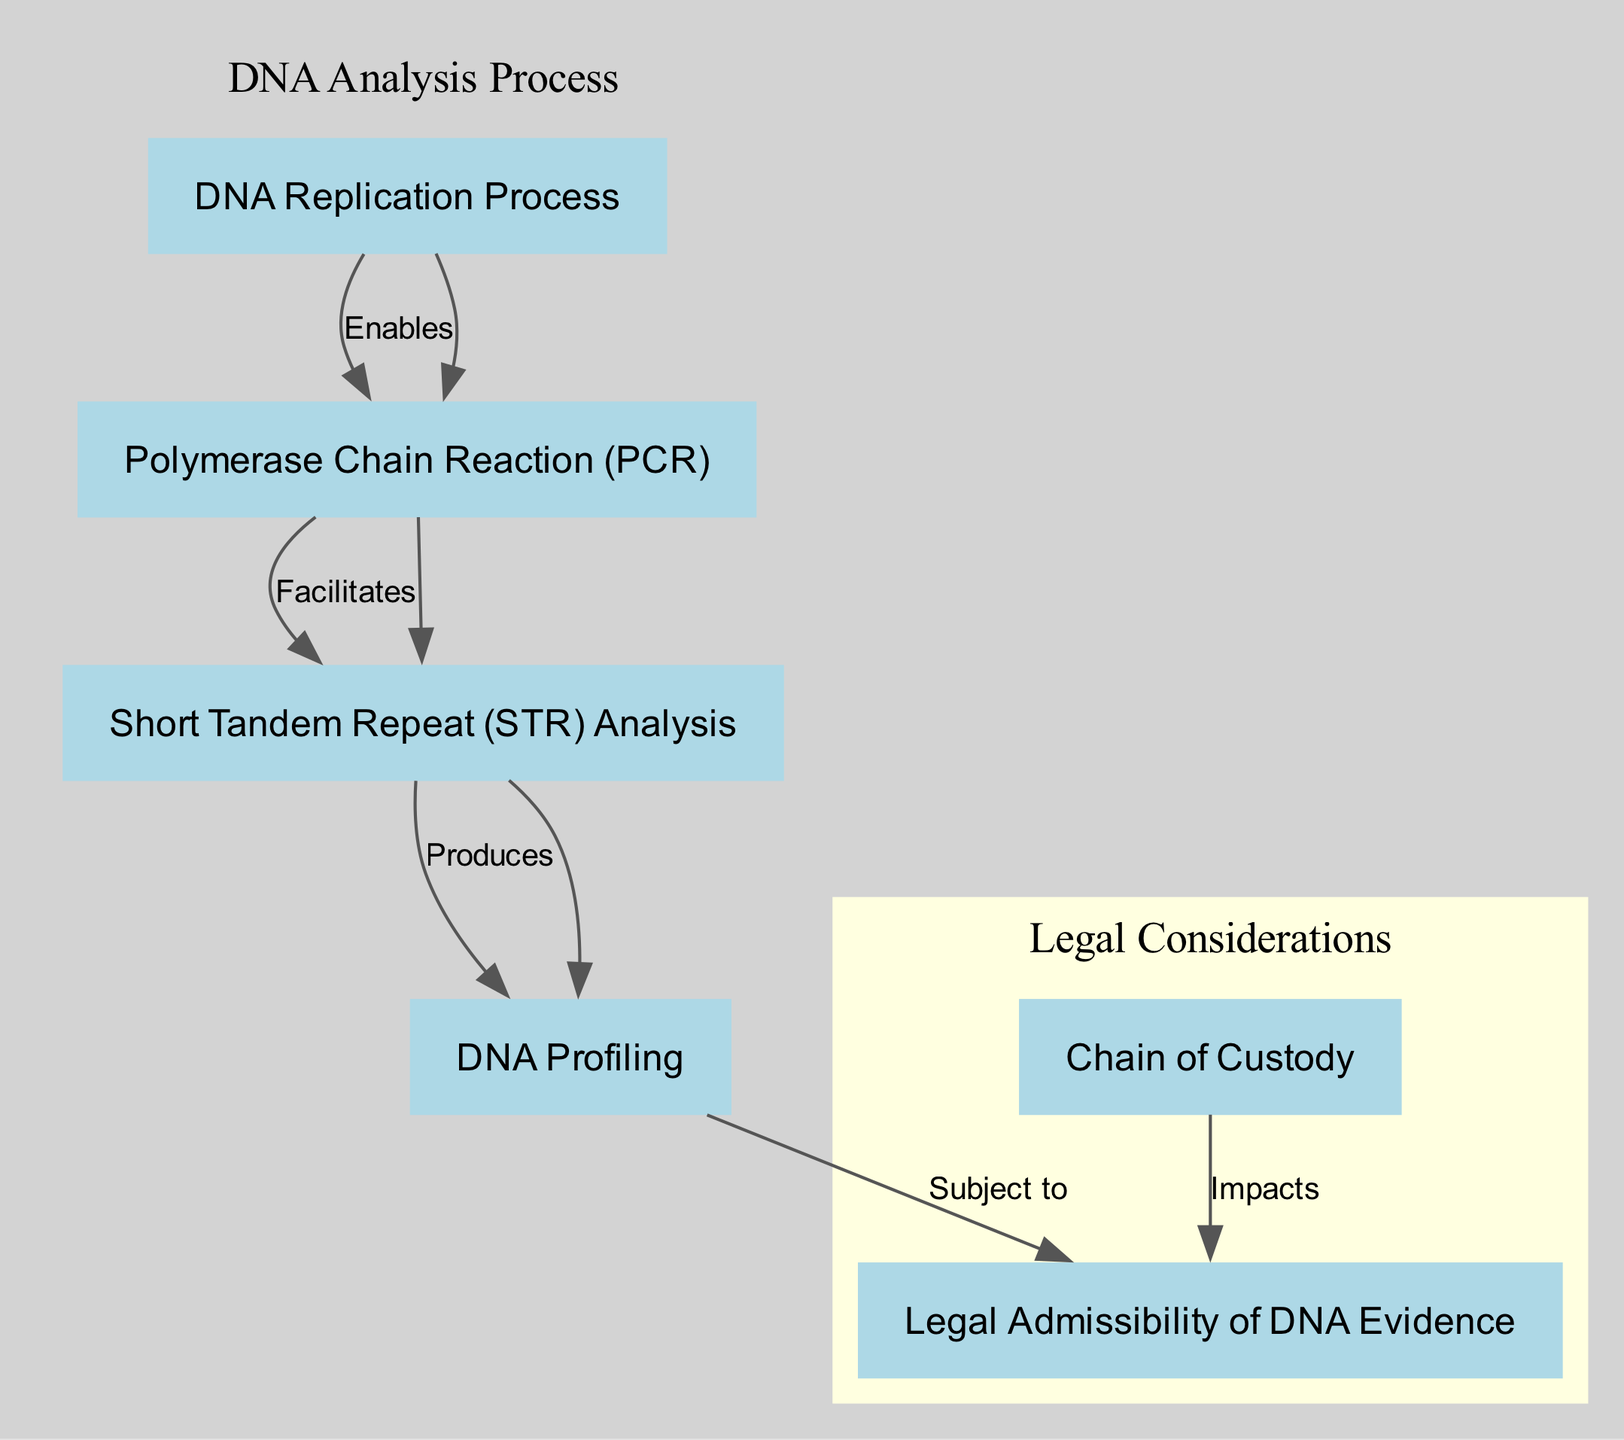What is the first process in DNA analysis? The diagram indicates that "DNA Replication Process" is the starting point of the DNA analysis workflow.
Answer: DNA Replication Process How many nodes are present in the diagram? By counting the nodes listed in the diagram, there are a total of six nodes: DNA Replication Process, Polymerase Chain Reaction (PCR), Short Tandem Repeat (STR) Analysis, DNA Profiling, Legal Admissibility of DNA Evidence, and Chain of Custody.
Answer: 6 What does PCR facilitate? According to the diagram, PCR facilitates the process of Short Tandem Repeat (STR) Analysis, as indicated by the directed edge labeled "Facilitates".
Answer: Short Tandem Repeat (STR) Analysis How does the chain of custody impact legal admissibility? The diagram shows an edge from "Chain of Custody" to "Legal Admissibility of DNA Evidence," indicating that the former directly impacts the latter's status in legal contexts.
Answer: Impacts What is produced by STR analysis? The diagram explicitly states that STR Analysis produces DNA Profiling, connected by an edge labeled "Produces".
Answer: DNA Profiling Which process enables the Polymerase Chain Reaction? In the diagram, the edge from "DNA Replication Process" to "Polymerase Chain Reaction (PCR)" is labeled "Enables," which signifies that the former is a prerequisite for PCR.
Answer: DNA Replication Process What is the relationship between DNA Profiling and legal admissibility? The diagram illustrates that DNA Profiling is subject to legal admissibility, indicated by the directional edge labeled "Subject to".
Answer: Subject to How are legal considerations grouped in the diagram? The diagram categorizes "Legal Admissibility of DNA Evidence" and "Chain of Custody" under the "Legal Considerations" cluster, visually representing their relationship within a separate section.
Answer: Legal Considerations What relationship exists between PCR and STR Analysis? The diagram indicates that PCR facilitates STR Analysis, which shows a direct support relationship between these two processes in DNA analysis.
Answer: Facilitates 